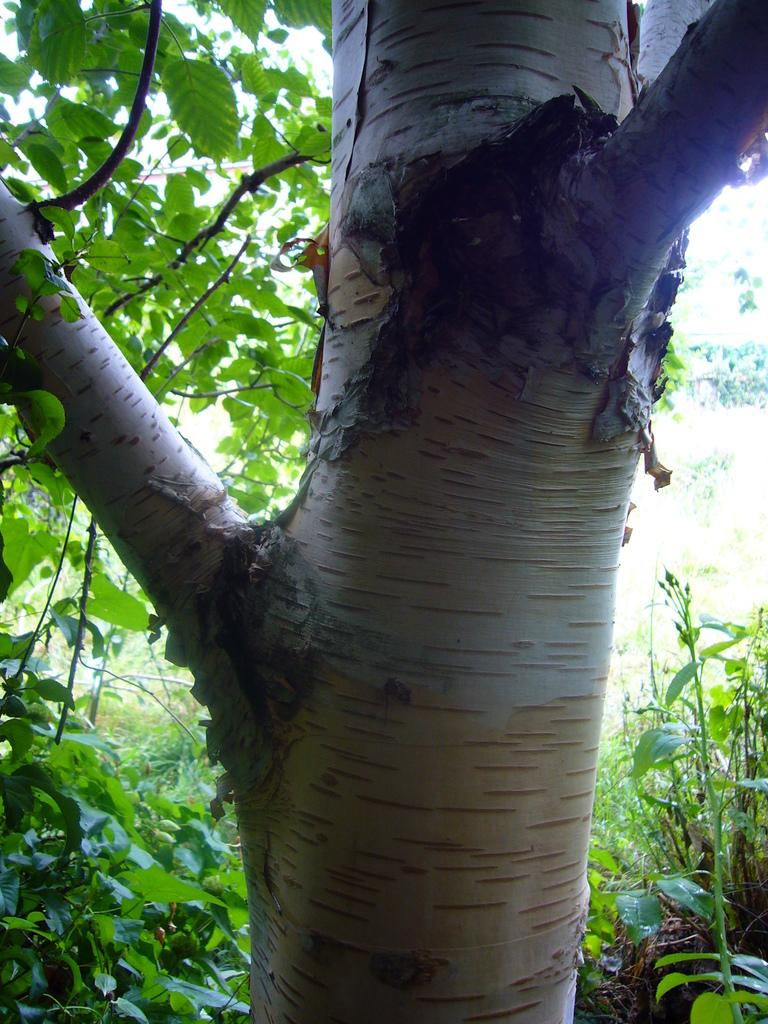What is the main subject of the image? The main subject of the image is a tree trunk. What features can be observed on the tree trunk? The tree trunk has branches. What else can be seen in the image besides the tree trunk? There are plants around the tree and leaves on the tree. Can you see any snails climbing on the tree trunk in the image? There are no snails visible in the image. What type of chalk is being used to draw on the tree trunk in the image? There is no chalk or drawing present on the tree trunk in the image. 